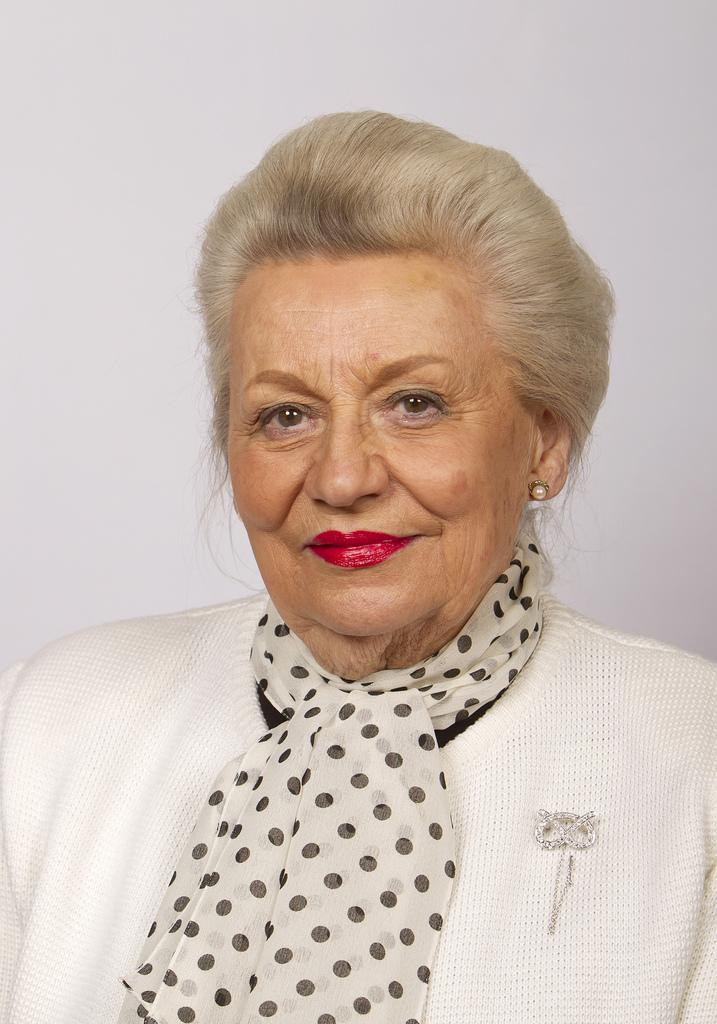Who is the main subject in the image? There is a woman in the image. What is the woman wearing in the image? The woman is wearing a scarf in the image. What is the color of the background in the image? The background of the image is white. How many giants can be seen in the image? There are no giants present in the image. Is the woman in the image the grandmother of the photographer? There is no information provided about the relationship between the woman and the photographer, so we cannot determine if she is the grandmother. 